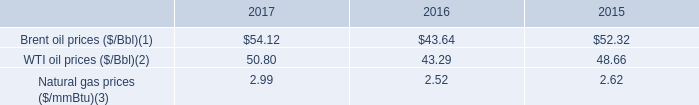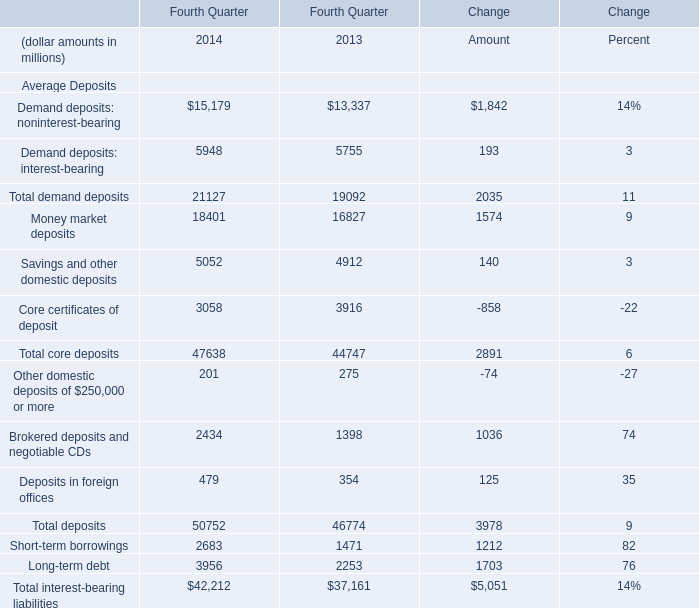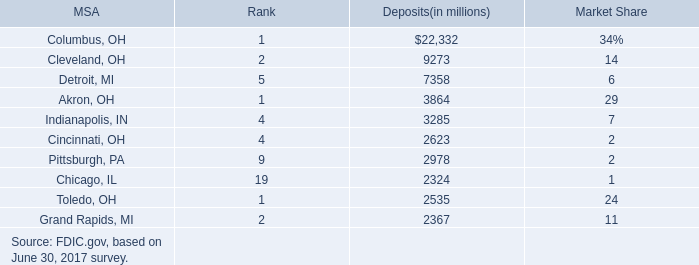what is the growth rate in wti oil prices from 2016 to 2017? 
Computations: ((50.80 - 43.29) / 43.29)
Answer: 0.17348. 